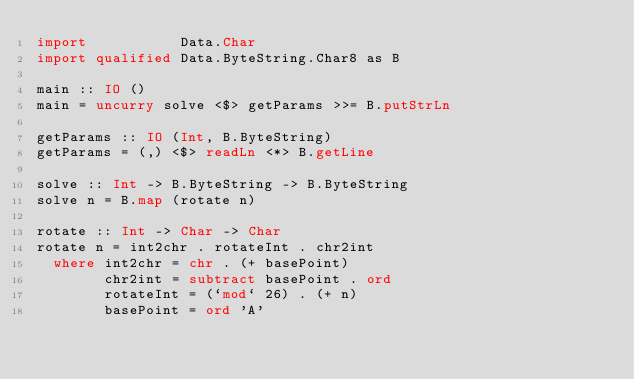<code> <loc_0><loc_0><loc_500><loc_500><_Haskell_>import           Data.Char
import qualified Data.ByteString.Char8 as B

main :: IO ()
main = uncurry solve <$> getParams >>= B.putStrLn

getParams :: IO (Int, B.ByteString)
getParams = (,) <$> readLn <*> B.getLine

solve :: Int -> B.ByteString -> B.ByteString
solve n = B.map (rotate n)

rotate :: Int -> Char -> Char
rotate n = int2chr . rotateInt . chr2int
  where int2chr = chr . (+ basePoint)
        chr2int = subtract basePoint . ord
        rotateInt = (`mod` 26) . (+ n)
        basePoint = ord 'A'
</code> 